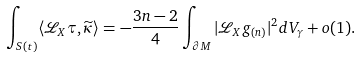Convert formula to latex. <formula><loc_0><loc_0><loc_500><loc_500>\int _ { S ( t ) } \langle { \mathcal { L } } _ { X } \tau , \widetilde { \kappa } \rangle = - \frac { 3 n - 2 } { 4 } \int _ { \partial M } | { \mathcal { L } } _ { X } g _ { ( n ) } | ^ { 2 } d V _ { \gamma } + o ( 1 ) .</formula> 